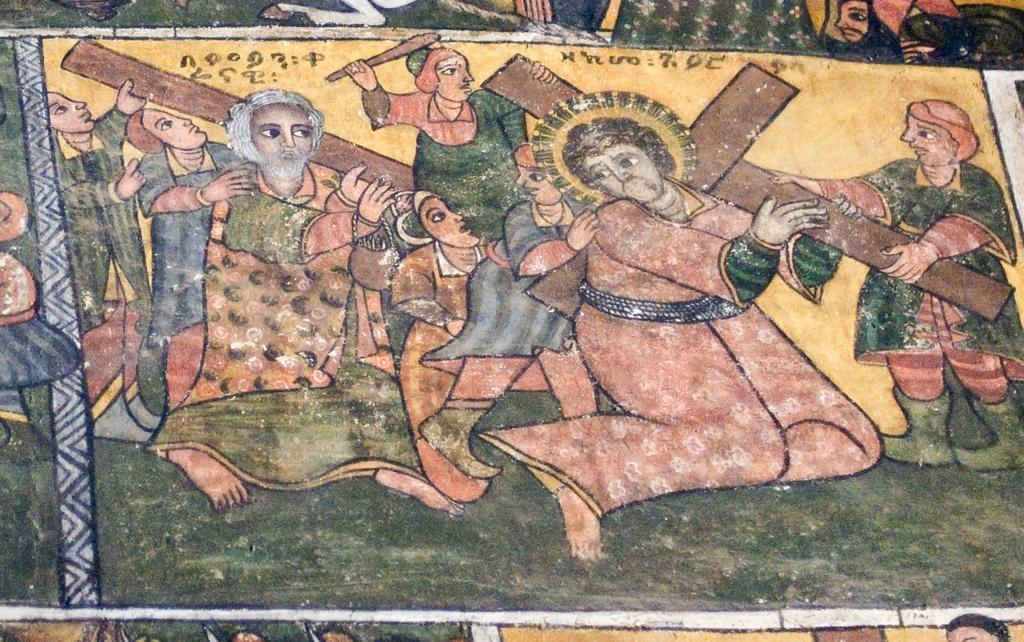What is the main subject of the image? There is a painting in the image. What can be seen in the painting? The painting contains people. What are some of the people in the painting doing? Some people in the painting are holding a cross. Are there any words or letters in the painting? Yes, there is text present in the painting. Is there a desk visible in the painting? There is no desk present in the painting; it only contains people and text. Can you see any dust particles in the painting? There are no dust particles visible in the painting, as it is a two-dimensional representation. 